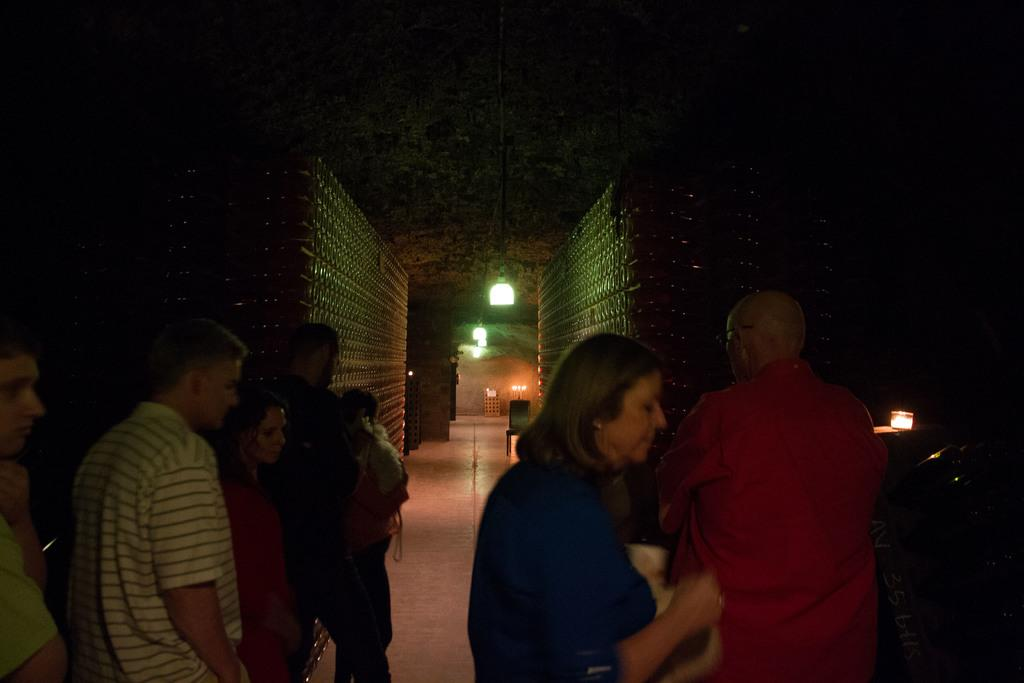What can be seen in the image involving human presence? There are people standing in the image. What are the people wearing? The people are wearing clothes. What can be seen illuminating the scene in the image? There are lights visible in the image. What is the surface beneath the people's feet in the image? The floor is visible in the image. How would you describe the overall lighting condition in the image? The background of the image is dark. What type of paint is being used by the people in the image? There is no indication of paint or painting activity in the image. What is the people's stance on supporting the jar in the image? There is no jar present in the image, so it is not possible to determine their stance on supporting it. 